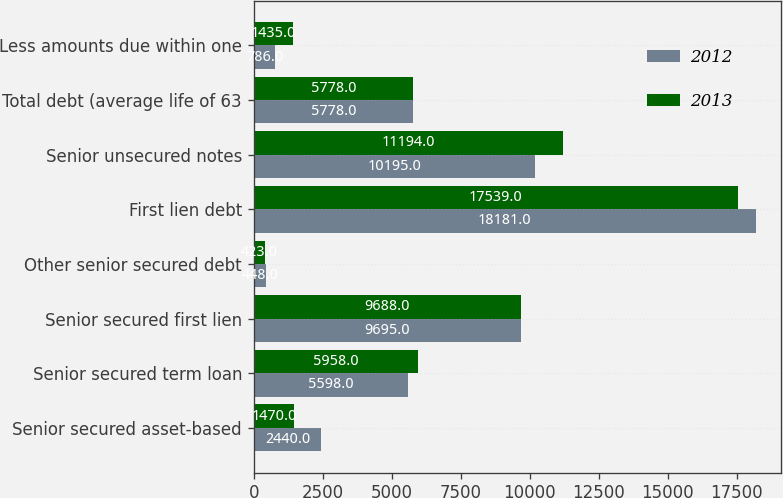<chart> <loc_0><loc_0><loc_500><loc_500><stacked_bar_chart><ecel><fcel>Senior secured asset-based<fcel>Senior secured term loan<fcel>Senior secured first lien<fcel>Other senior secured debt<fcel>First lien debt<fcel>Senior unsecured notes<fcel>Total debt (average life of 63<fcel>Less amounts due within one<nl><fcel>2012<fcel>2440<fcel>5598<fcel>9695<fcel>448<fcel>18181<fcel>10195<fcel>5778<fcel>786<nl><fcel>2013<fcel>1470<fcel>5958<fcel>9688<fcel>423<fcel>17539<fcel>11194<fcel>5778<fcel>1435<nl></chart> 